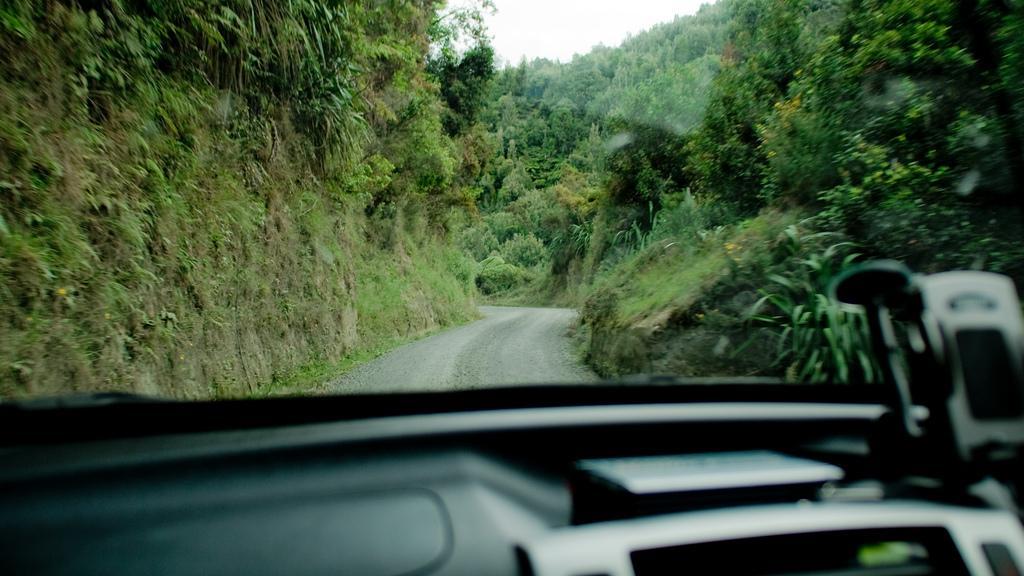Describe this image in one or two sentences. In this image we can see many trees and plants. There is a road in the image. We can see the inside of a vehicle. 